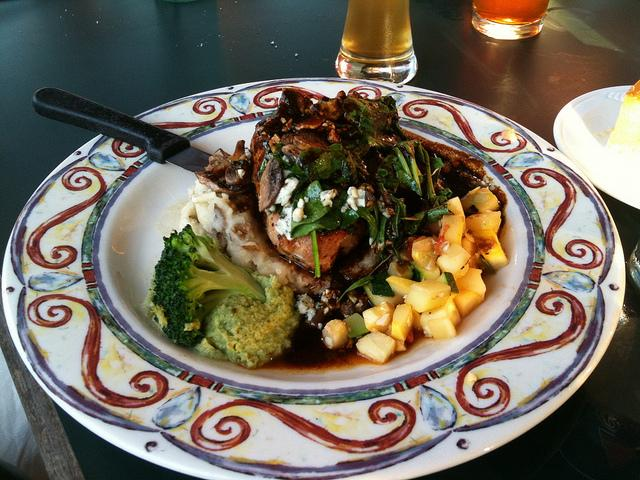What utensil is on the plate? Please explain your reasoning. knife. It is a sharp utensil with a black handle. 